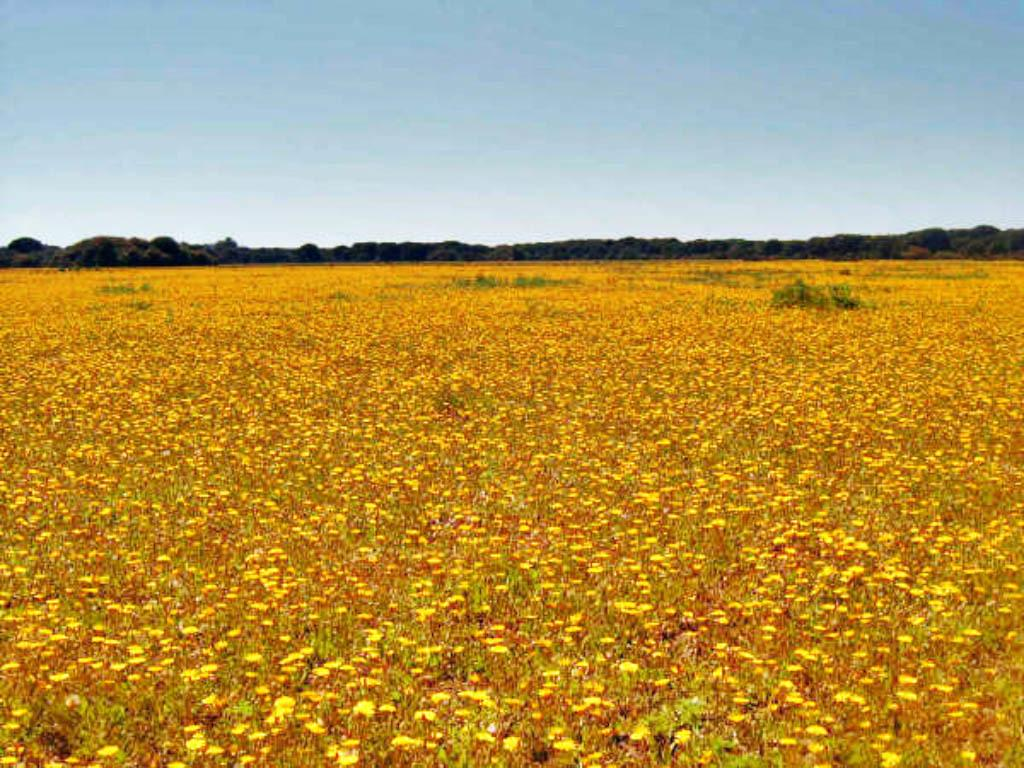What type of landscape is depicted in the image? There is an agricultural field in the image. What other natural elements can be seen in the image? There are trees in the image. What is visible in the background of the image? The sky is visible in the image. What type of stove is present in the image? There is no stove present in the image; it features an agricultural field, trees, and the sky. How does the wind affect the head of the person in the image? There is no person present in the image, so it is not possible to determine the effect of the wind on their head. 